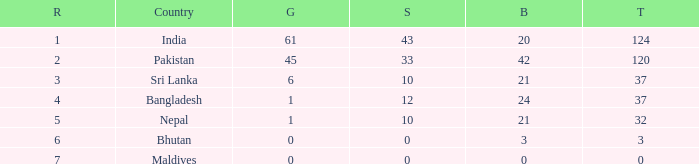Which Gold has a Nation of sri lanka, and a Silver smaller than 10? None. 